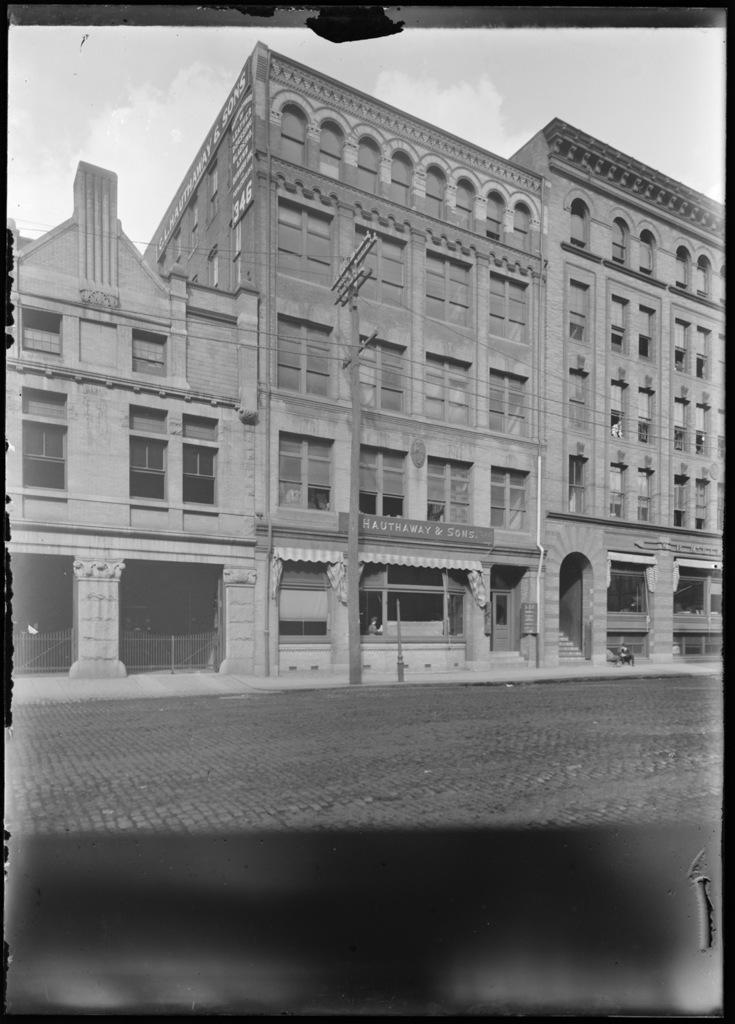In one or two sentences, can you explain what this image depicts? In this image we can see a building, there are some windows, railings, wires, stairs and pillars, in the background, we can see the sky with clouds. 